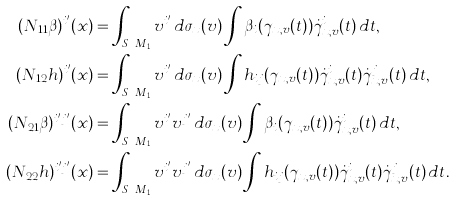Convert formula to latex. <formula><loc_0><loc_0><loc_500><loc_500>( N _ { 1 1 } \beta ) ^ { i ^ { \prime } } ( x ) & = \int _ { S _ { x } M _ { 1 } } v ^ { i ^ { \prime } } \, d \sigma _ { x } ( v ) \int \beta _ { i } ( \gamma _ { x , v } ( t ) ) \dot { \gamma } _ { x , v } ^ { i } ( t ) \, d t , \\ ( N _ { 1 2 } h ) ^ { i ^ { \prime } } ( x ) & = \int _ { S _ { x } M _ { 1 } } v ^ { i ^ { \prime } } \, d \sigma _ { x } ( v ) \int h _ { i j } ( \gamma _ { x , v } ( t ) ) \dot { \gamma } _ { x , v } ^ { i } ( t ) \dot { \gamma } _ { x , v } ^ { j } ( t ) \, d t , \\ ( N _ { 2 1 } \beta ) ^ { i ^ { \prime } j ^ { \prime } } ( x ) & = \int _ { S _ { x } M _ { 1 } } v ^ { i ^ { \prime } } v ^ { j ^ { \prime } } \, d \sigma _ { x } ( v ) \int \beta _ { i } ( \gamma _ { x , v } ( t ) ) \dot { \gamma } _ { x , v } ^ { i } ( t ) \, d t , \\ ( N _ { 2 2 } h ) ^ { i ^ { \prime } j ^ { \prime } } ( x ) & = \int _ { S _ { x } M _ { 1 } } v ^ { i ^ { \prime } } v ^ { j ^ { \prime } } \, d \sigma _ { x } ( v ) \int h _ { i j } ( \gamma _ { x , v } ( t ) ) \dot { \gamma } _ { x , v } ^ { i } ( t ) \dot { \gamma } _ { x , v } ^ { j } ( t ) \, d t .</formula> 